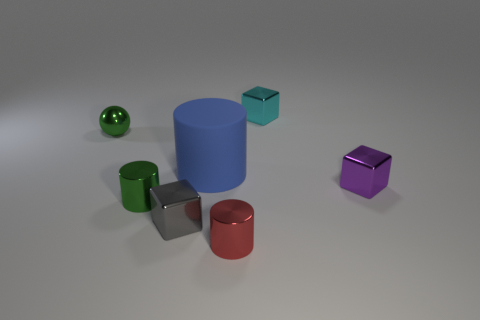Is there anything else that has the same size as the matte cylinder?
Your answer should be compact. No. What shape is the tiny green object that is in front of the blue cylinder?
Your response must be concise. Cylinder. How many small green objects are the same shape as the big blue rubber thing?
Make the answer very short. 1. Is the number of small cylinders that are to the left of the large object the same as the number of green things in front of the tiny red object?
Provide a short and direct response. No. Is there a tiny purple object that has the same material as the small green ball?
Make the answer very short. Yes. Is the material of the big blue thing the same as the gray object?
Your answer should be very brief. No. What number of green things are either big things or metallic spheres?
Make the answer very short. 1. Are there more tiny metal blocks that are in front of the metallic sphere than blue rubber cylinders?
Your answer should be compact. Yes. Is there a thing that has the same color as the ball?
Keep it short and to the point. Yes. The blue cylinder has what size?
Your response must be concise. Large. 